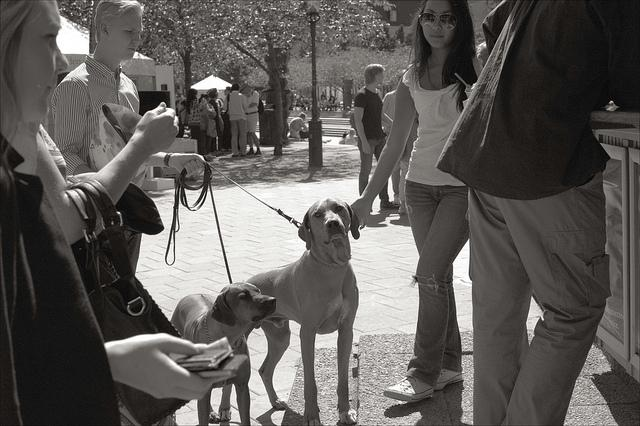How many dogs are held on the leashes?

Choices:
A) three
B) two
C) one
D) four two 